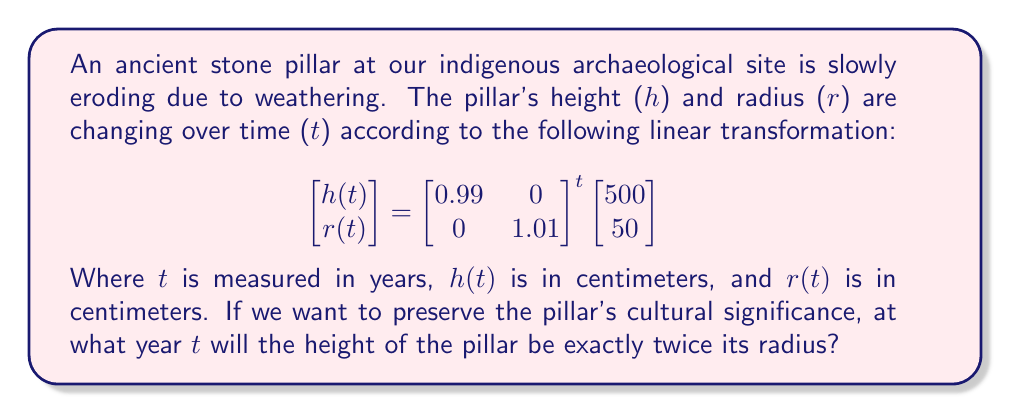Could you help me with this problem? Let's approach this step-by-step:

1) First, we need to understand what the transformation does:
   - Each year, the height decreases by 1% (multiplied by 0.99)
   - Each year, the radius increases by 1% (multiplied by 1.01)

2) We can express this as:
   $$h(t) = 500 \cdot 0.99^t$$
   $$r(t) = 50 \cdot 1.01^t$$

3) We want to find t when $h(t) = 2r(t)$. So we set up the equation:
   $$500 \cdot 0.99^t = 2(50 \cdot 1.01^t)$$

4) Simplify the right side:
   $$500 \cdot 0.99^t = 100 \cdot 1.01^t$$

5) Divide both sides by 100:
   $$5 \cdot 0.99^t = 1.01^t$$

6) Take the natural log of both sides:
   $$\ln(5) + t\ln(0.99) = t\ln(1.01)$$

7) Rearrange to isolate t:
   $$\ln(5) = t\ln(1.01) - t\ln(0.99) = t(\ln(1.01) - \ln(0.99))$$

8) Solve for t:
   $$t = \frac{\ln(5)}{\ln(1.01) - \ln(0.99)} \approx 80.9$$

9) Since we're dealing with whole years, we round up to 81 years.
Answer: 81 years 